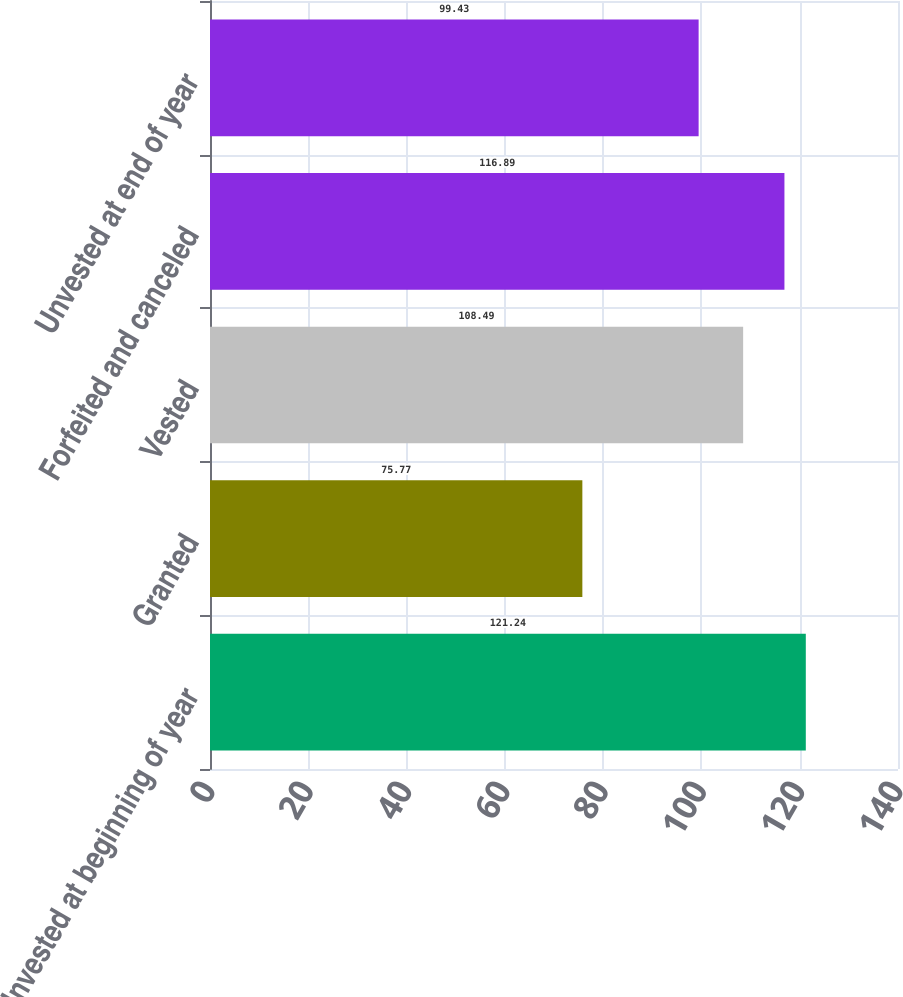Convert chart. <chart><loc_0><loc_0><loc_500><loc_500><bar_chart><fcel>Unvested at beginning of year<fcel>Granted<fcel>Vested<fcel>Forfeited and canceled<fcel>Unvested at end of year<nl><fcel>121.24<fcel>75.77<fcel>108.49<fcel>116.89<fcel>99.43<nl></chart> 